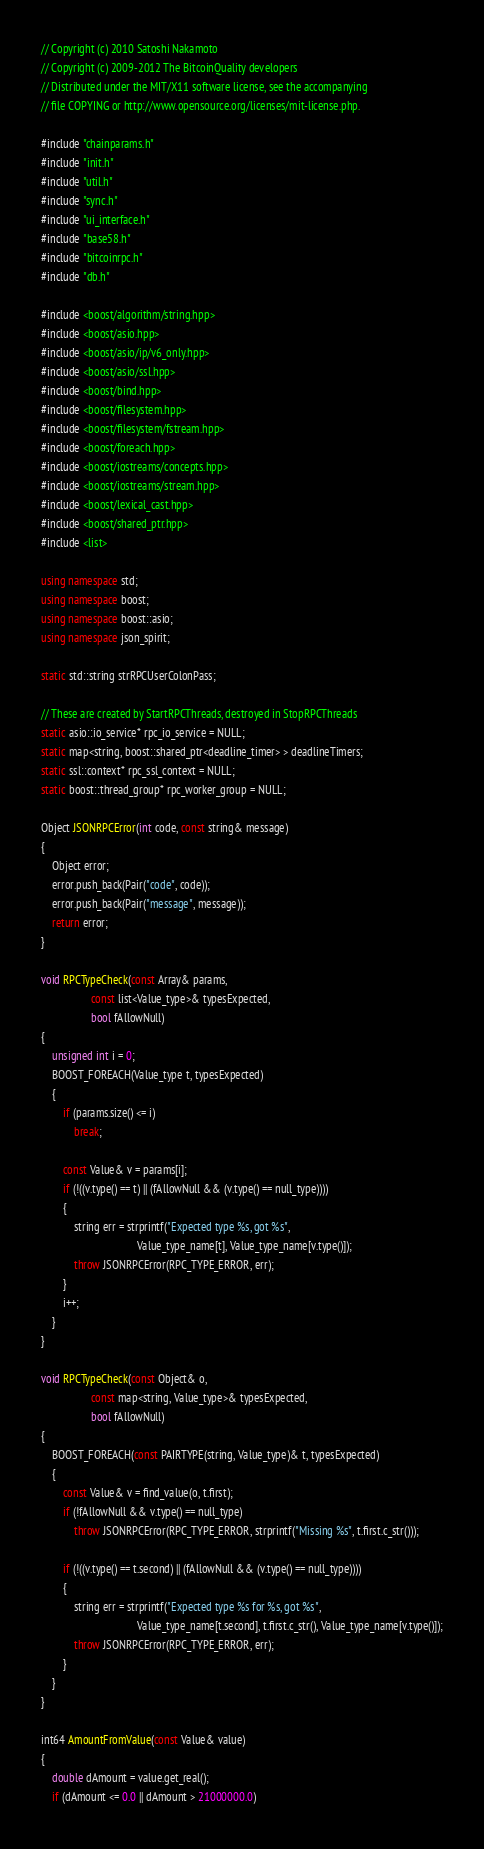Convert code to text. <code><loc_0><loc_0><loc_500><loc_500><_C++_>// Copyright (c) 2010 Satoshi Nakamoto
// Copyright (c) 2009-2012 The BitcoinQuality developers
// Distributed under the MIT/X11 software license, see the accompanying
// file COPYING or http://www.opensource.org/licenses/mit-license.php.

#include "chainparams.h"
#include "init.h"
#include "util.h"
#include "sync.h"
#include "ui_interface.h"
#include "base58.h"
#include "bitcoinrpc.h"
#include "db.h"

#include <boost/algorithm/string.hpp>
#include <boost/asio.hpp>
#include <boost/asio/ip/v6_only.hpp>
#include <boost/asio/ssl.hpp>
#include <boost/bind.hpp>
#include <boost/filesystem.hpp>
#include <boost/filesystem/fstream.hpp>
#include <boost/foreach.hpp>
#include <boost/iostreams/concepts.hpp>
#include <boost/iostreams/stream.hpp>
#include <boost/lexical_cast.hpp>
#include <boost/shared_ptr.hpp>
#include <list>

using namespace std;
using namespace boost;
using namespace boost::asio;
using namespace json_spirit;

static std::string strRPCUserColonPass;

// These are created by StartRPCThreads, destroyed in StopRPCThreads
static asio::io_service* rpc_io_service = NULL;
static map<string, boost::shared_ptr<deadline_timer> > deadlineTimers;
static ssl::context* rpc_ssl_context = NULL;
static boost::thread_group* rpc_worker_group = NULL;

Object JSONRPCError(int code, const string& message)
{
    Object error;
    error.push_back(Pair("code", code));
    error.push_back(Pair("message", message));
    return error;
}

void RPCTypeCheck(const Array& params,
                  const list<Value_type>& typesExpected,
                  bool fAllowNull)
{
    unsigned int i = 0;
    BOOST_FOREACH(Value_type t, typesExpected)
    {
        if (params.size() <= i)
            break;

        const Value& v = params[i];
        if (!((v.type() == t) || (fAllowNull && (v.type() == null_type))))
        {
            string err = strprintf("Expected type %s, got %s",
                                   Value_type_name[t], Value_type_name[v.type()]);
            throw JSONRPCError(RPC_TYPE_ERROR, err);
        }
        i++;
    }
}

void RPCTypeCheck(const Object& o,
                  const map<string, Value_type>& typesExpected,
                  bool fAllowNull)
{
    BOOST_FOREACH(const PAIRTYPE(string, Value_type)& t, typesExpected)
    {
        const Value& v = find_value(o, t.first);
        if (!fAllowNull && v.type() == null_type)
            throw JSONRPCError(RPC_TYPE_ERROR, strprintf("Missing %s", t.first.c_str()));

        if (!((v.type() == t.second) || (fAllowNull && (v.type() == null_type))))
        {
            string err = strprintf("Expected type %s for %s, got %s",
                                   Value_type_name[t.second], t.first.c_str(), Value_type_name[v.type()]);
            throw JSONRPCError(RPC_TYPE_ERROR, err);
        }
    }
}

int64 AmountFromValue(const Value& value)
{
    double dAmount = value.get_real();
    if (dAmount <= 0.0 || dAmount > 21000000.0)</code> 